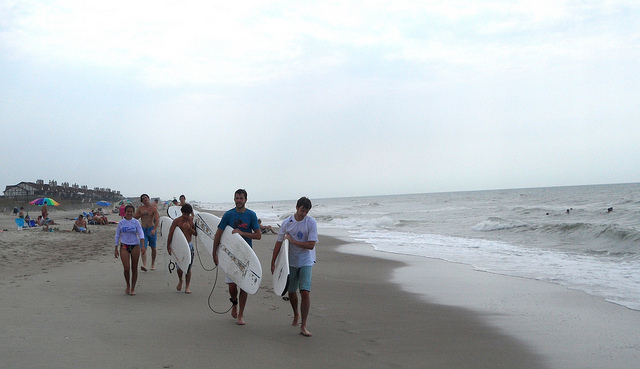<image>What uniforms are the men wearing? Ambiguous to answer accurately, but they could be wearing shorts, swimsuits or a shirt and swim trunks. Is the man's surfboard name brand? I don't know if the man's surfboard is a name brand. It can be seen as 'billabong'. What uniforms are the men wearing? It is ambiguous what uniforms the men are wearing. It can be seen that they are wearing shorts, swimsuits, or t-shirts and swim trunks. Is the man's surfboard name brand? I am not sure if the man's surfboard is name brand. It can be both name brand and not name brand. 